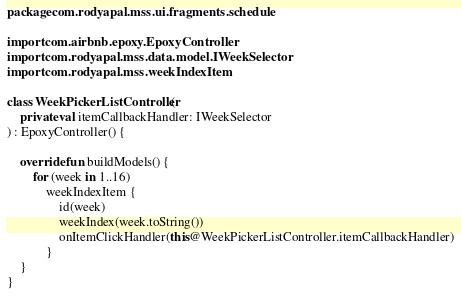Convert code to text. <code><loc_0><loc_0><loc_500><loc_500><_Kotlin_>package com.rodyapal.mss.ui.fragments.schedule

import com.airbnb.epoxy.EpoxyController
import com.rodyapal.mss.data.model.IWeekSelector
import com.rodyapal.mss.weekIndexItem

class WeekPickerListController(
	private val itemCallbackHandler: IWeekSelector
) : EpoxyController() {

	override fun buildModels() {
		for (week in 1..16)
			weekIndexItem {
				id(week)
				weekIndex(week.toString())
				onItemClickHandler(this@WeekPickerListController.itemCallbackHandler)
			}
	}
}</code> 